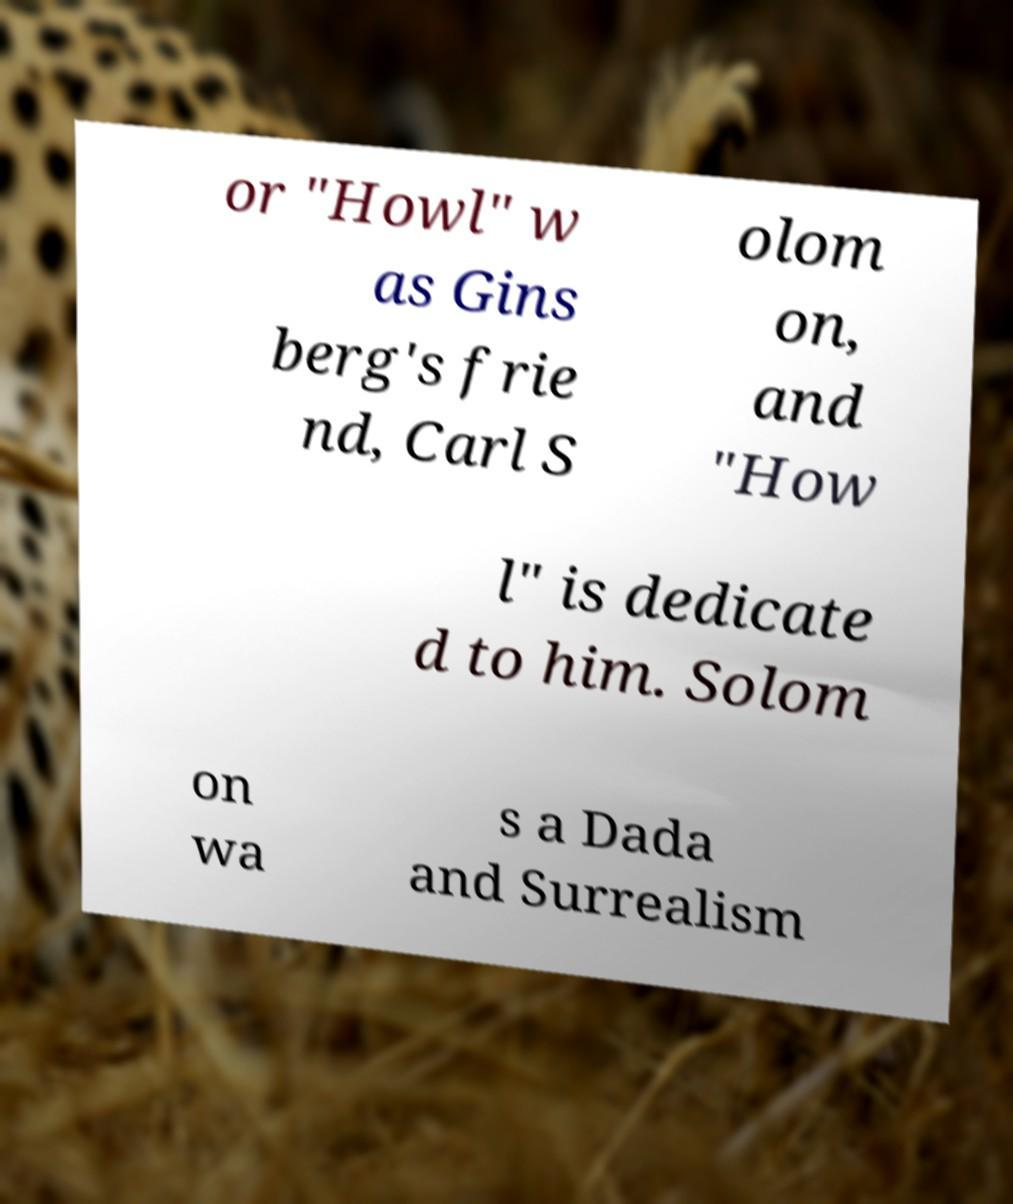Please read and relay the text visible in this image. What does it say? or "Howl" w as Gins berg's frie nd, Carl S olom on, and "How l" is dedicate d to him. Solom on wa s a Dada and Surrealism 